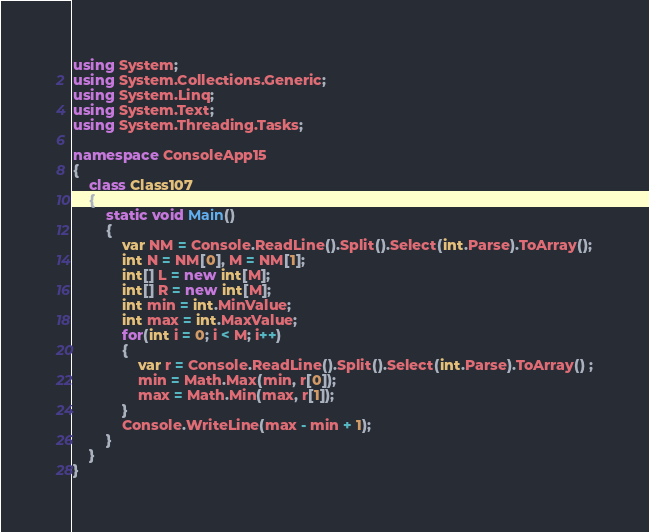Convert code to text. <code><loc_0><loc_0><loc_500><loc_500><_C#_>using System;
using System.Collections.Generic;
using System.Linq;
using System.Text;
using System.Threading.Tasks;

namespace ConsoleApp15
{
    class Class107
    {
        static void Main()
        {
            var NM = Console.ReadLine().Split().Select(int.Parse).ToArray();
            int N = NM[0], M = NM[1];
            int[] L = new int[M];
            int[] R = new int[M];
            int min = int.MinValue;
            int max = int.MaxValue;
            for(int i = 0; i < M; i++)
            {
                var r = Console.ReadLine().Split().Select(int.Parse).ToArray() ;
                min = Math.Max(min, r[0]);
                max = Math.Min(max, r[1]);
            }
            Console.WriteLine(max - min + 1);
        }
    }
}
</code> 